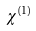<formula> <loc_0><loc_0><loc_500><loc_500>\chi ^ { ( 1 ) }</formula> 